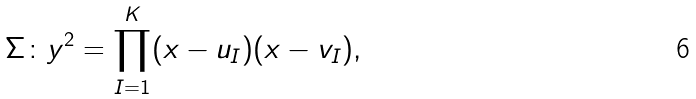<formula> <loc_0><loc_0><loc_500><loc_500>\Sigma \colon y ^ { 2 } = \prod _ { I = 1 } ^ { K } ( x - u _ { I } ) ( x - v _ { I } ) ,</formula> 